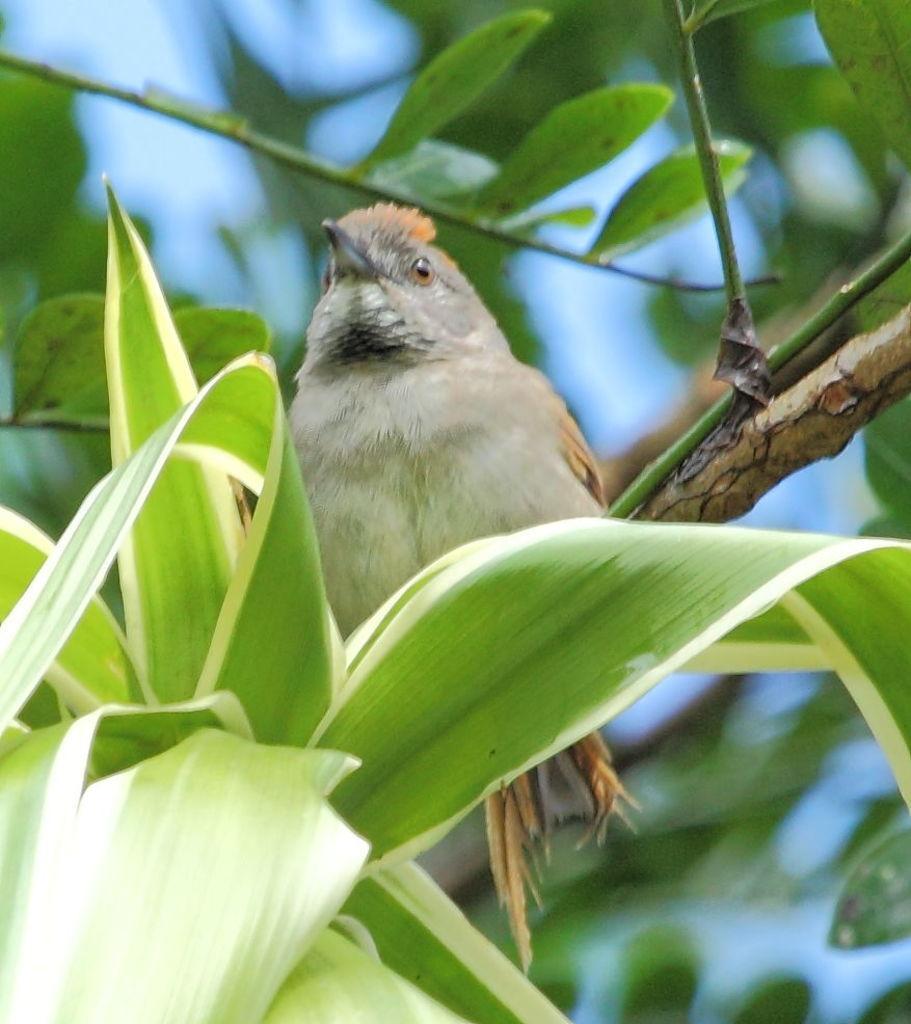Can you describe this image briefly? In this image we can see a bird. In front of the bird we can see the leaves. The background of the image is blurred. 